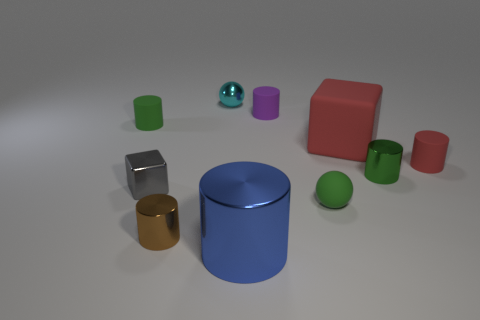Subtract 2 cylinders. How many cylinders are left? 4 Subtract all red cylinders. How many cylinders are left? 5 Subtract all brown shiny cylinders. How many cylinders are left? 5 Subtract all brown cylinders. Subtract all brown blocks. How many cylinders are left? 5 Subtract all balls. How many objects are left? 8 Add 9 large cubes. How many large cubes exist? 10 Subtract 0 cyan cylinders. How many objects are left? 10 Subtract all tiny purple metal cubes. Subtract all large red objects. How many objects are left? 9 Add 6 small cyan shiny balls. How many small cyan shiny balls are left? 7 